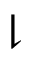Convert formula to latex. <formula><loc_0><loc_0><loc_500><loc_500>\downharpoonright</formula> 